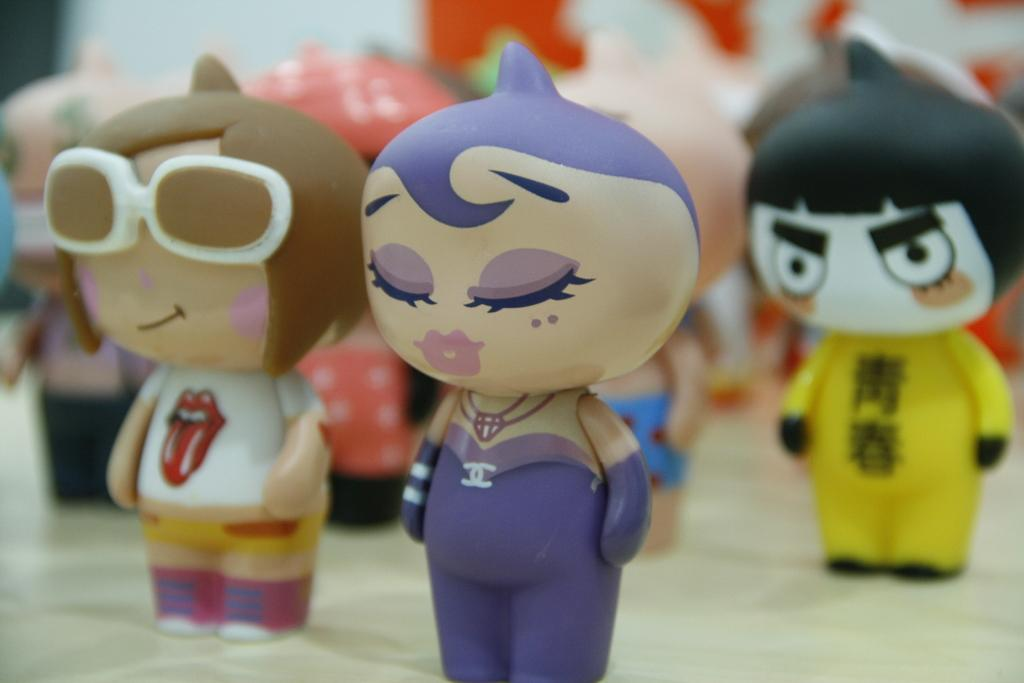What types of objects are present in the image? There are different toys in the image. How are the toys arranged in the image? The toys are arranged one after the other. Which toy is located in the middle of the arrangement? There is a girl toy in the middle of the arrangement. What is a unique feature of the toy beside the girl toy? The toy beside the girl toy has spectacles on its face. How does the girl toy apply the brake during her voyage in the image? There is no girl toy, brake, or voyage present in the image; it only features different toys arranged one after the other. 